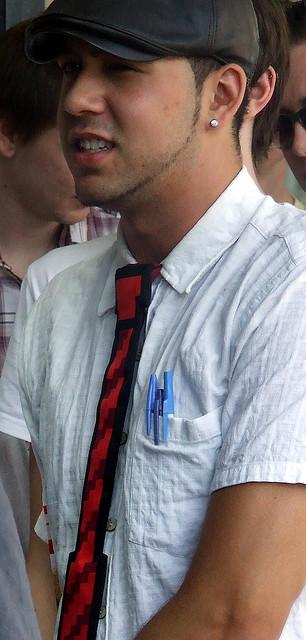What company is known for making the objects in the man's pocket? Please explain your reasoning. bic. There are pens, not food items or computers, in the man's pocket. 